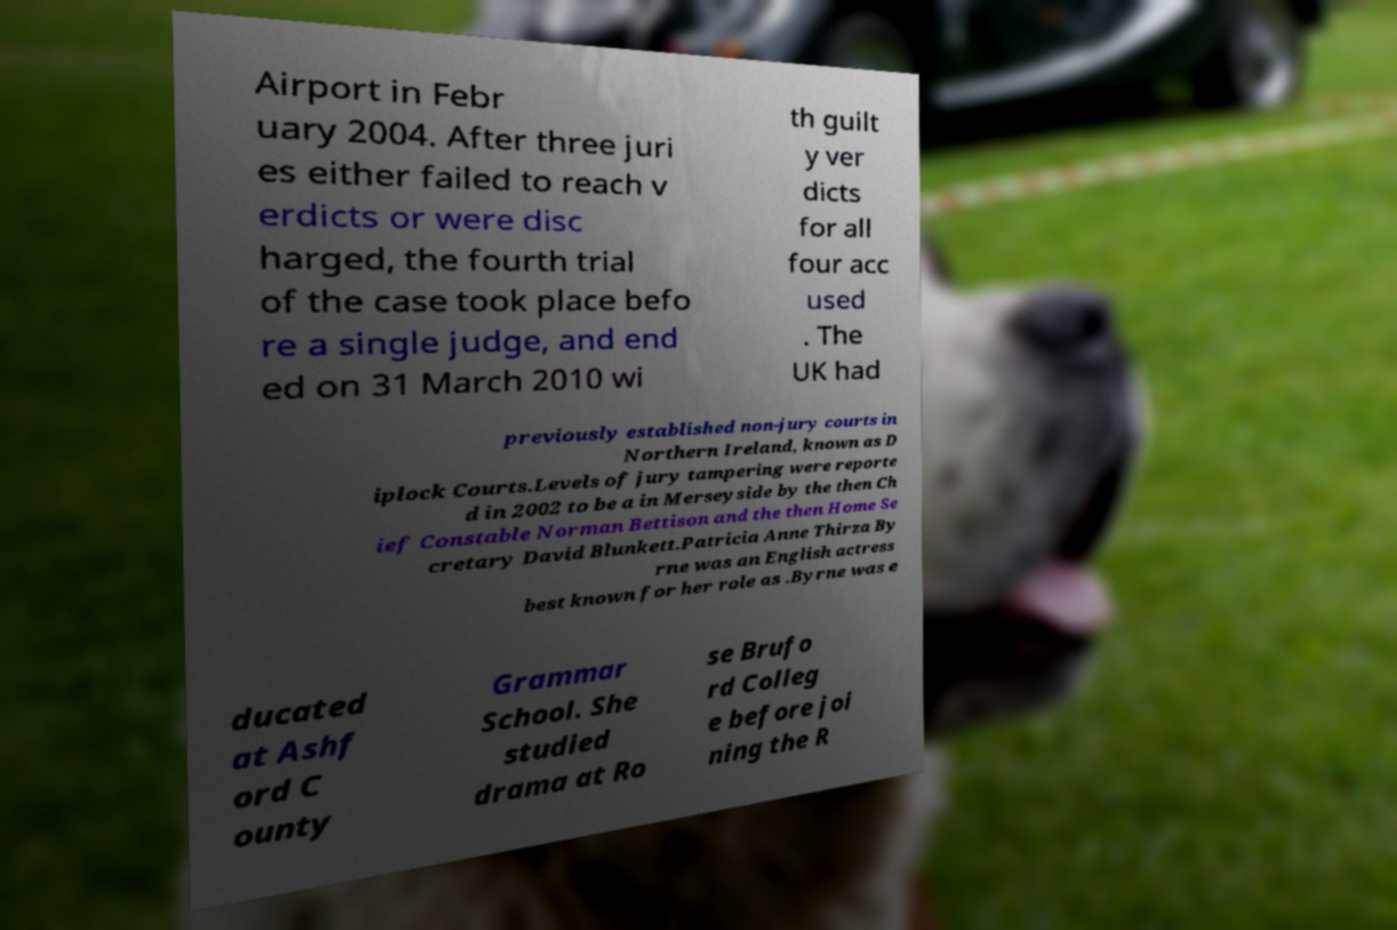Can you read and provide the text displayed in the image?This photo seems to have some interesting text. Can you extract and type it out for me? Airport in Febr uary 2004. After three juri es either failed to reach v erdicts or were disc harged, the fourth trial of the case took place befo re a single judge, and end ed on 31 March 2010 wi th guilt y ver dicts for all four acc used . The UK had previously established non-jury courts in Northern Ireland, known as D iplock Courts.Levels of jury tampering were reporte d in 2002 to be a in Merseyside by the then Ch ief Constable Norman Bettison and the then Home Se cretary David Blunkett.Patricia Anne Thirza By rne was an English actress best known for her role as .Byrne was e ducated at Ashf ord C ounty Grammar School. She studied drama at Ro se Brufo rd Colleg e before joi ning the R 